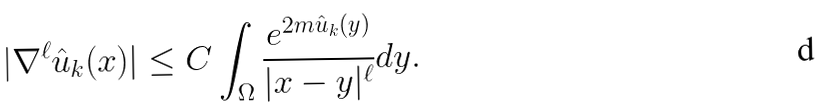<formula> <loc_0><loc_0><loc_500><loc_500>| \nabla ^ { \ell } \hat { u } _ { k } ( x ) | \leq C \int _ { \Omega } \frac { e ^ { 2 m \hat { u } _ { k } ( y ) } } { | x - y | ^ { \ell } } d y .</formula> 